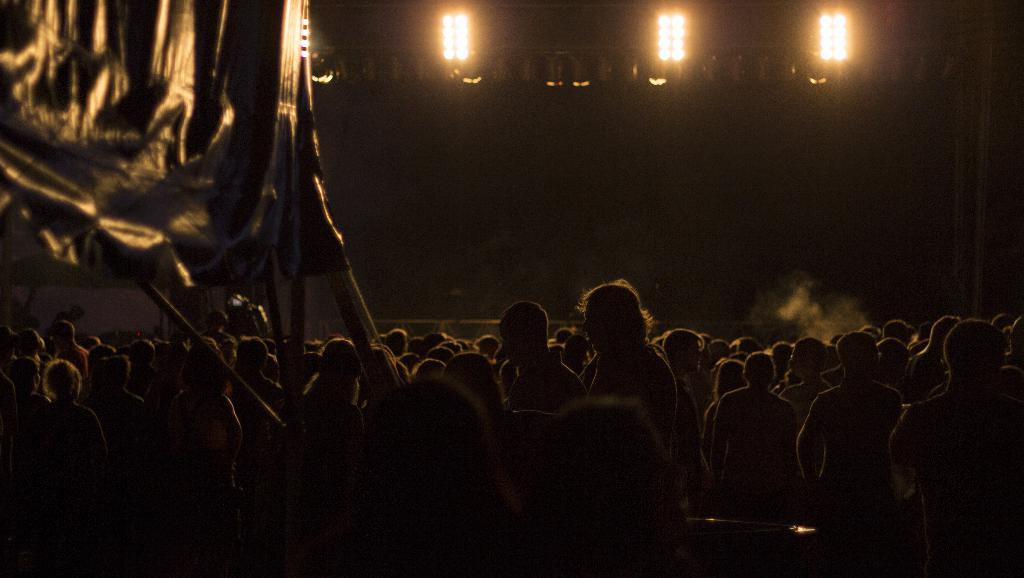Who or what can be seen at the bottom side of the image? There are people at the bottom side of the image. What is located in the top left side of the image? There is a canvas in the top left side of the image. What can be found at the top side of the image? There are lights at the top side of the image. How many potatoes are present on the canvas in the image? There are no potatoes present on the canvas in the image. Can you describe the behavior of the ants in the image? There are no ants present in the image. 